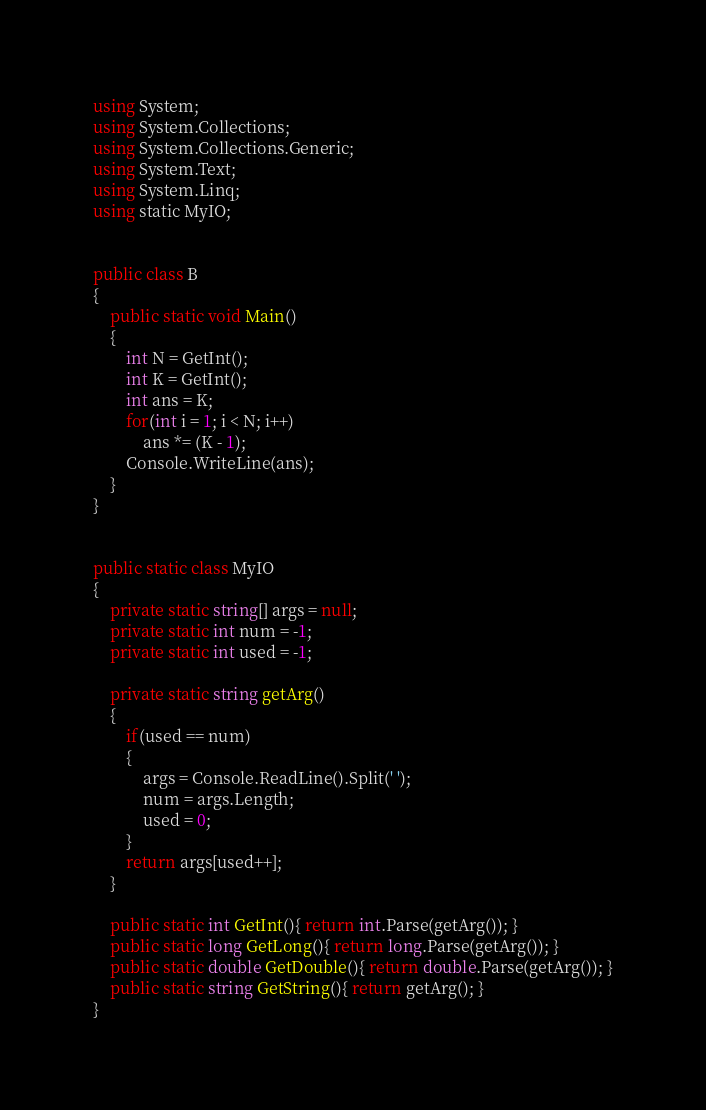<code> <loc_0><loc_0><loc_500><loc_500><_C#_>using System;
using System.Collections;
using System.Collections.Generic;
using System.Text;
using System.Linq;
using static MyIO;


public class B
{
	public static void Main()	
	{
		int N = GetInt();
		int K = GetInt();
		int ans = K;
		for(int i = 1; i < N; i++)
			ans *= (K - 1);
		Console.WriteLine(ans);
	}
}


public static class MyIO
{
	private static string[] args = null;
	private static int num = -1;
	private static int used = -1;

	private static string getArg()
	{
		if(used == num)
		{
			args = Console.ReadLine().Split(' ');
			num = args.Length;
			used = 0;
		}
		return args[used++];
	}

	public static int GetInt(){ return int.Parse(getArg()); }
	public static long GetLong(){ return long.Parse(getArg()); }
	public static double GetDouble(){ return double.Parse(getArg()); }
	public static string GetString(){ return getArg(); }
}
</code> 